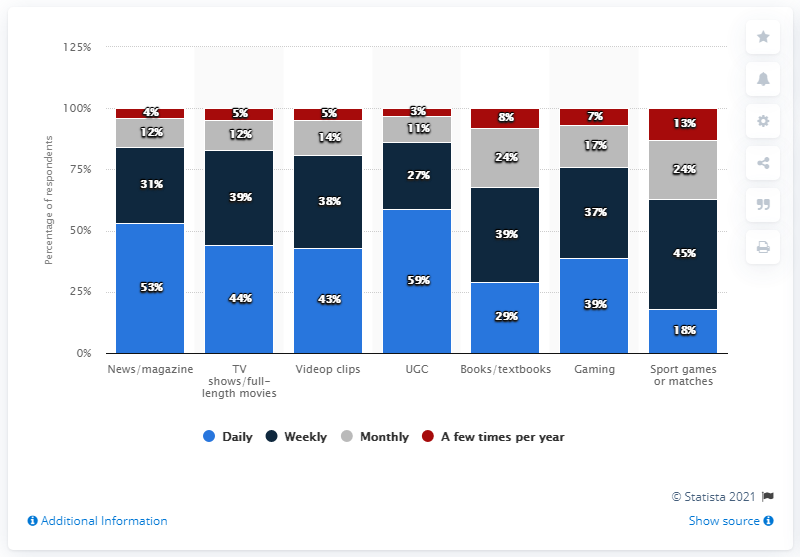Indicate a few pertinent items in this graphic. Among the respondents, 39% reported accessing Gaming Daily. The median of all the gray bars is 14. 